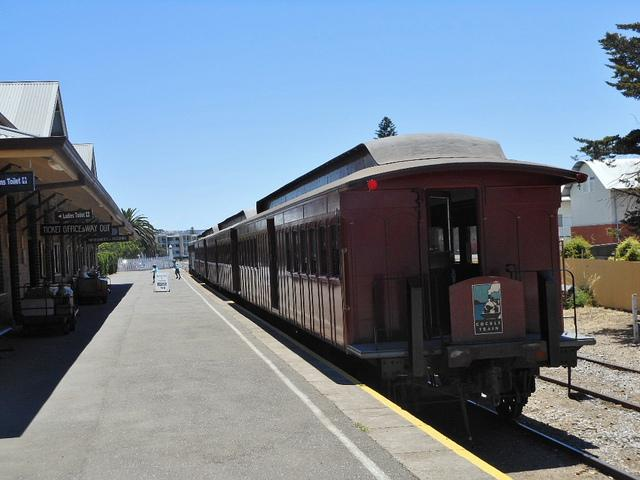What might the red light mean? Please explain your reasoning. unavailable. It shows that there might be a problem and it is not available. 